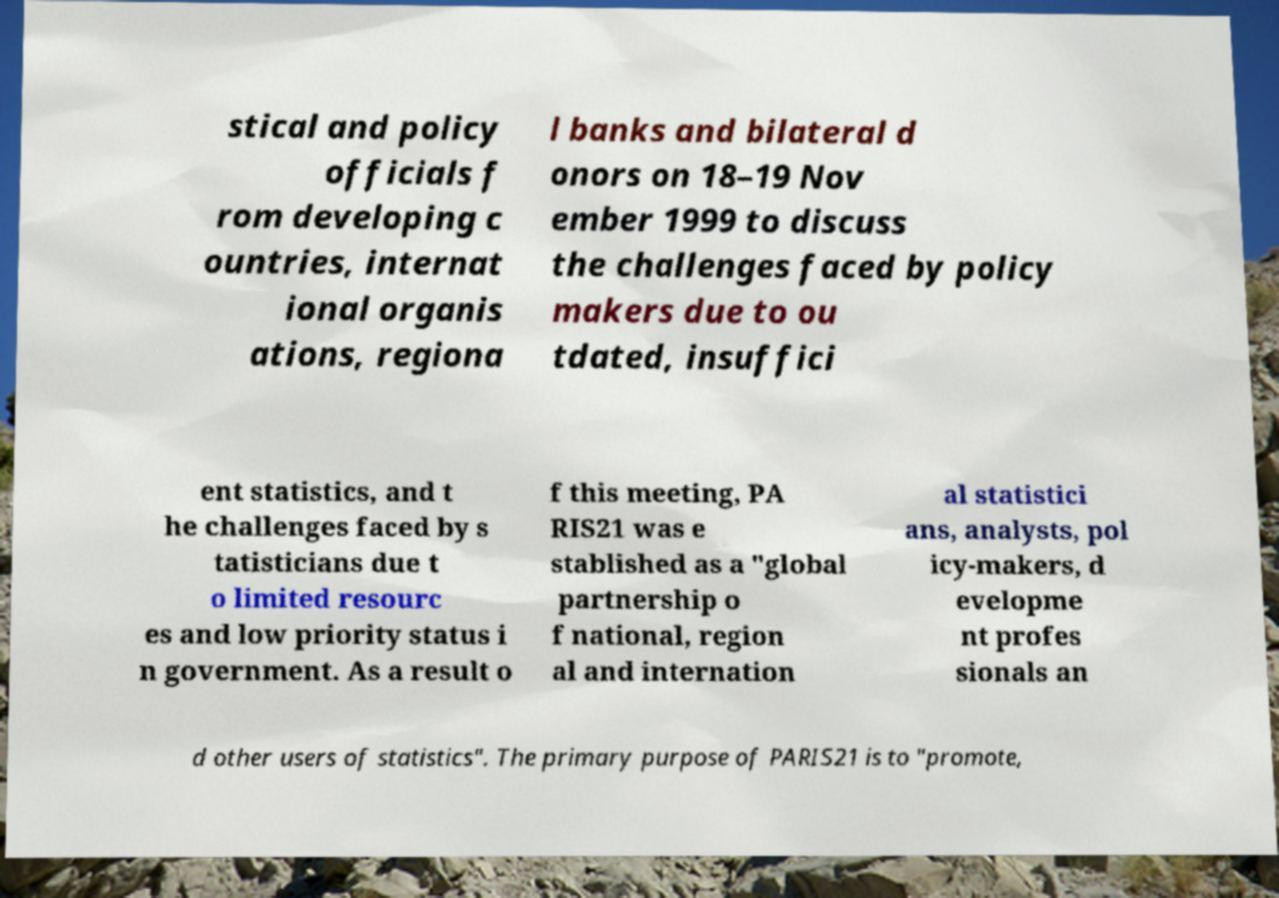Could you assist in decoding the text presented in this image and type it out clearly? stical and policy officials f rom developing c ountries, internat ional organis ations, regiona l banks and bilateral d onors on 18–19 Nov ember 1999 to discuss the challenges faced by policy makers due to ou tdated, insuffici ent statistics, and t he challenges faced by s tatisticians due t o limited resourc es and low priority status i n government. As a result o f this meeting, PA RIS21 was e stablished as a "global partnership o f national, region al and internation al statistici ans, analysts, pol icy-makers, d evelopme nt profes sionals an d other users of statistics". The primary purpose of PARIS21 is to "promote, 